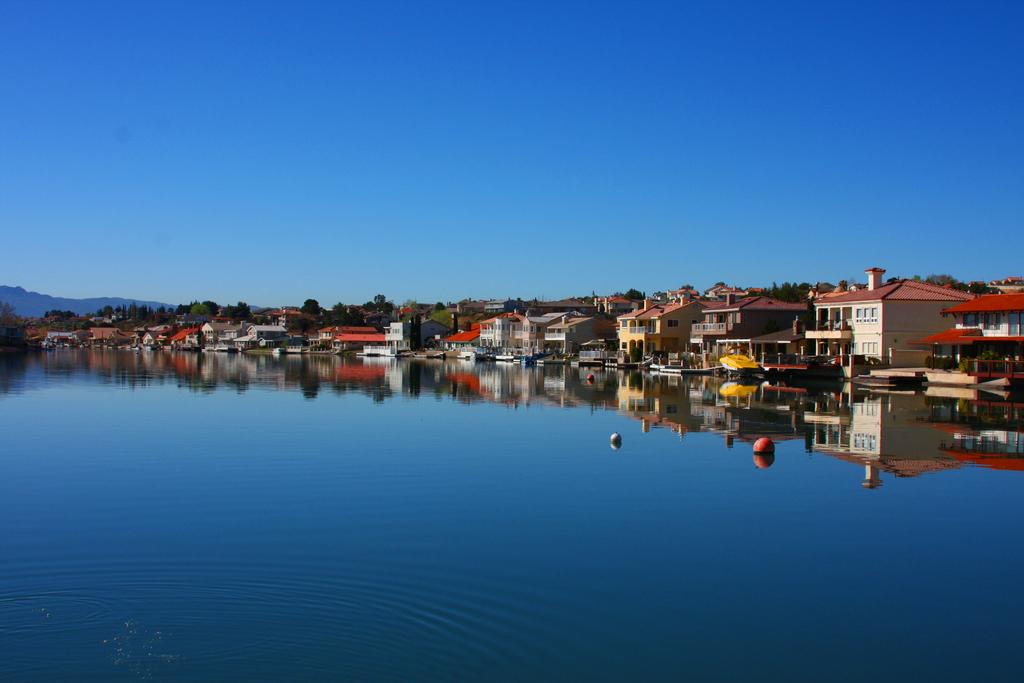What type of natural feature is at the bottom of the image? There is a river at the bottom of the image. What structures can be seen in the background of the image? There are buildings in the background of the image. What type of vegetation is present in the background of the image? There are trees in the background of the image. What geographical feature is visible in the background of the image? There is a hill in the background of the image. What is visible in the sky in the background of the image? The sky is visible in the background of the image. What type of zipper can be seen on the river in the image? There is no zipper present on the river in the image. How many jellyfish are swimming in the river in the image? There are no jellyfish present in the river in the image. 